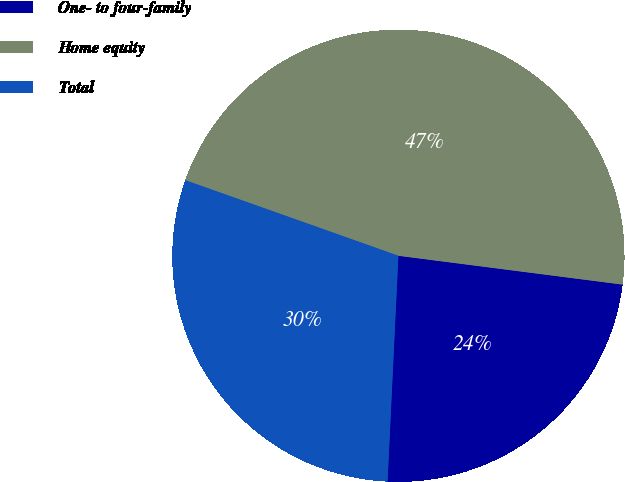<chart> <loc_0><loc_0><loc_500><loc_500><pie_chart><fcel>One- to four-family<fcel>Home equity<fcel>Total<nl><fcel>23.73%<fcel>46.61%<fcel>29.66%<nl></chart> 